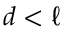<formula> <loc_0><loc_0><loc_500><loc_500>d < \ell</formula> 